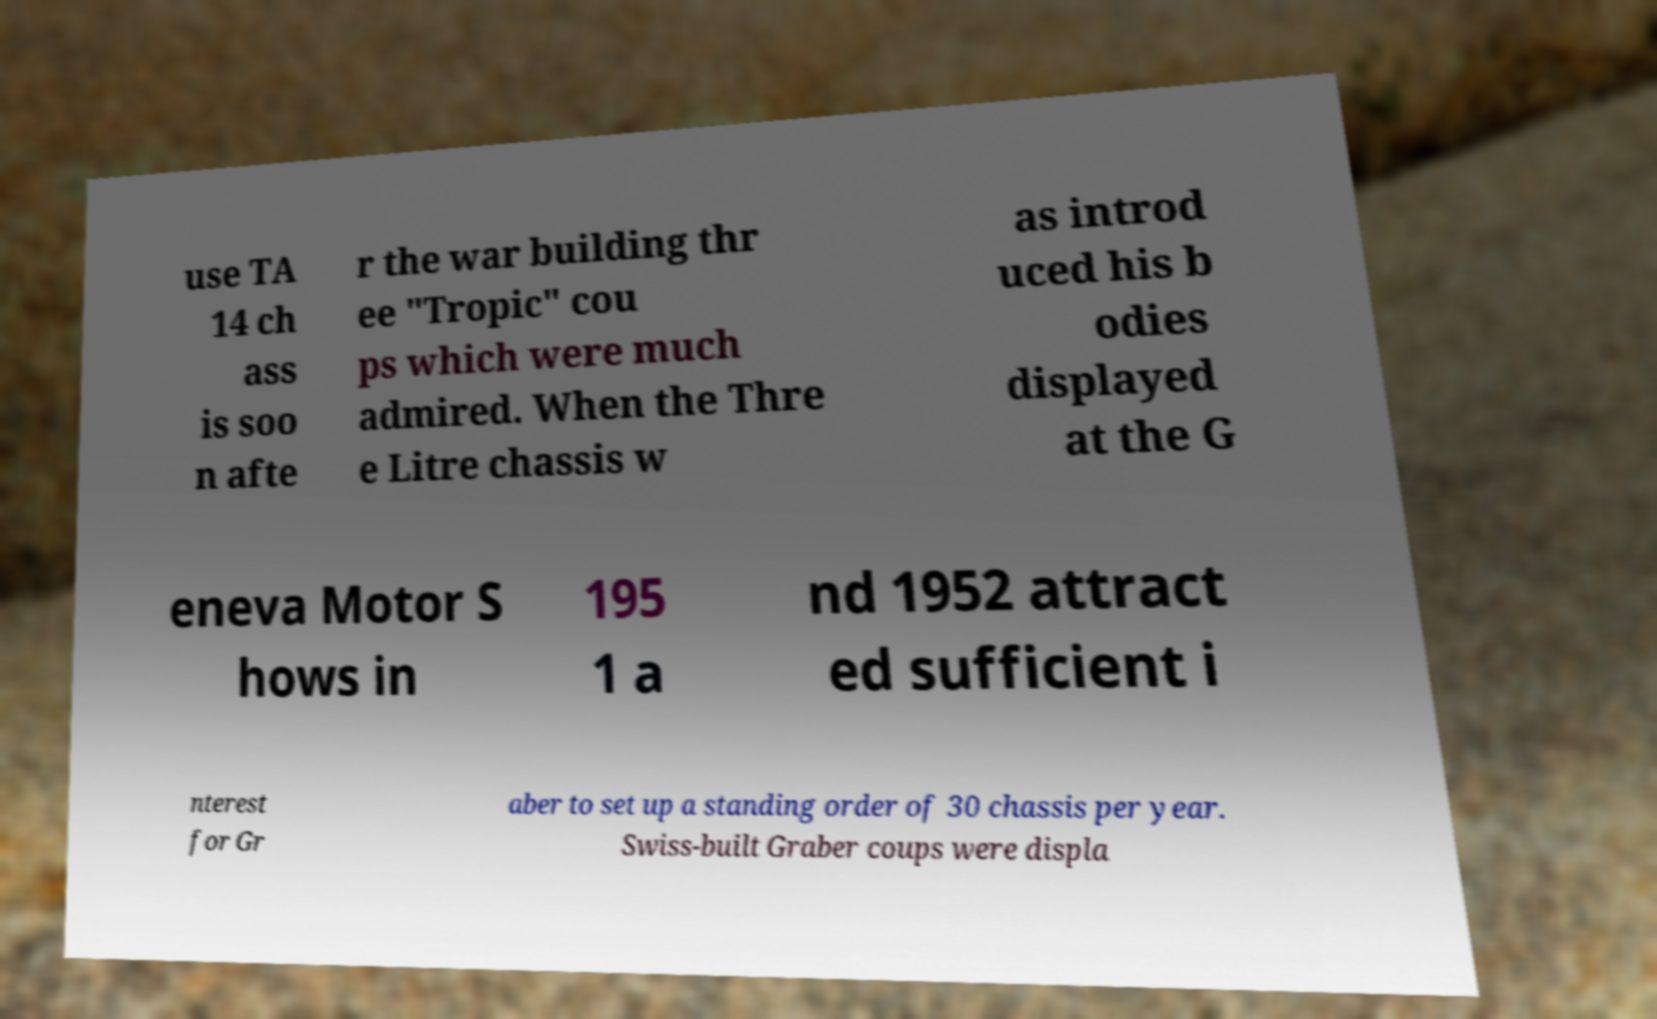Please identify and transcribe the text found in this image. use TA 14 ch ass is soo n afte r the war building thr ee "Tropic" cou ps which were much admired. When the Thre e Litre chassis w as introd uced his b odies displayed at the G eneva Motor S hows in 195 1 a nd 1952 attract ed sufficient i nterest for Gr aber to set up a standing order of 30 chassis per year. Swiss-built Graber coups were displa 